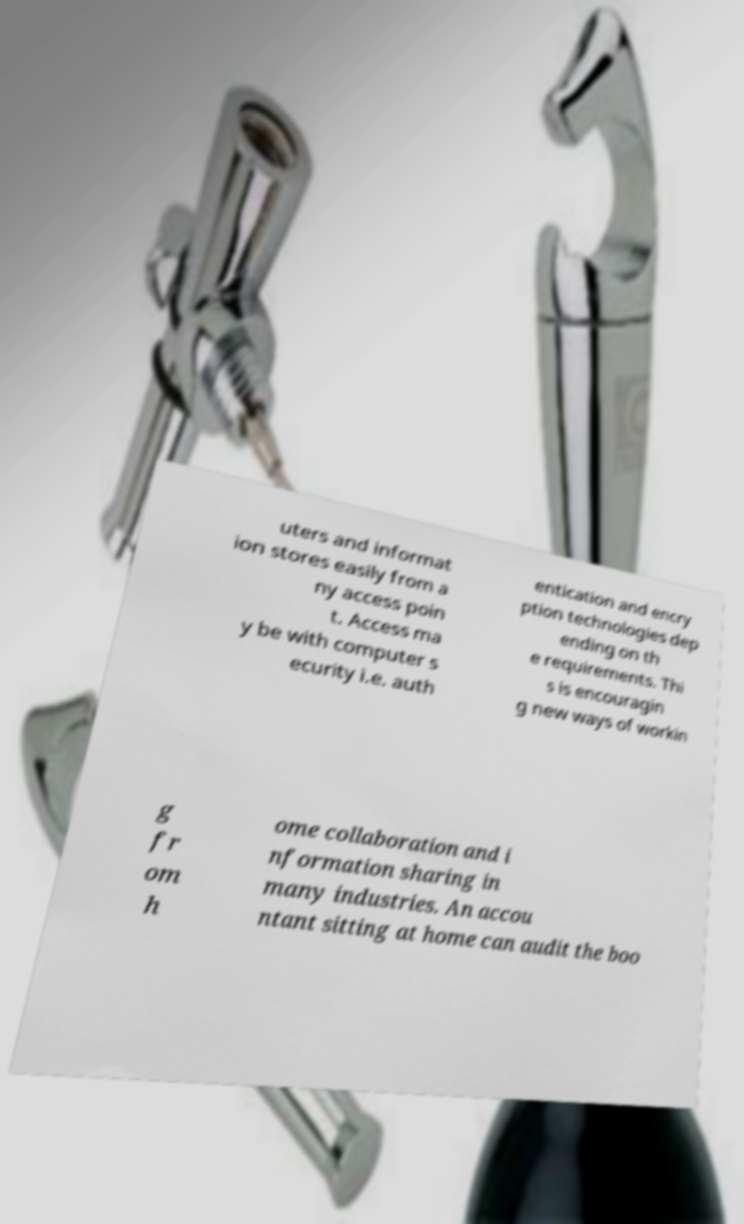What messages or text are displayed in this image? I need them in a readable, typed format. uters and informat ion stores easily from a ny access poin t. Access ma y be with computer s ecurity i.e. auth entication and encry ption technologies dep ending on th e requirements. Thi s is encouragin g new ways of workin g fr om h ome collaboration and i nformation sharing in many industries. An accou ntant sitting at home can audit the boo 